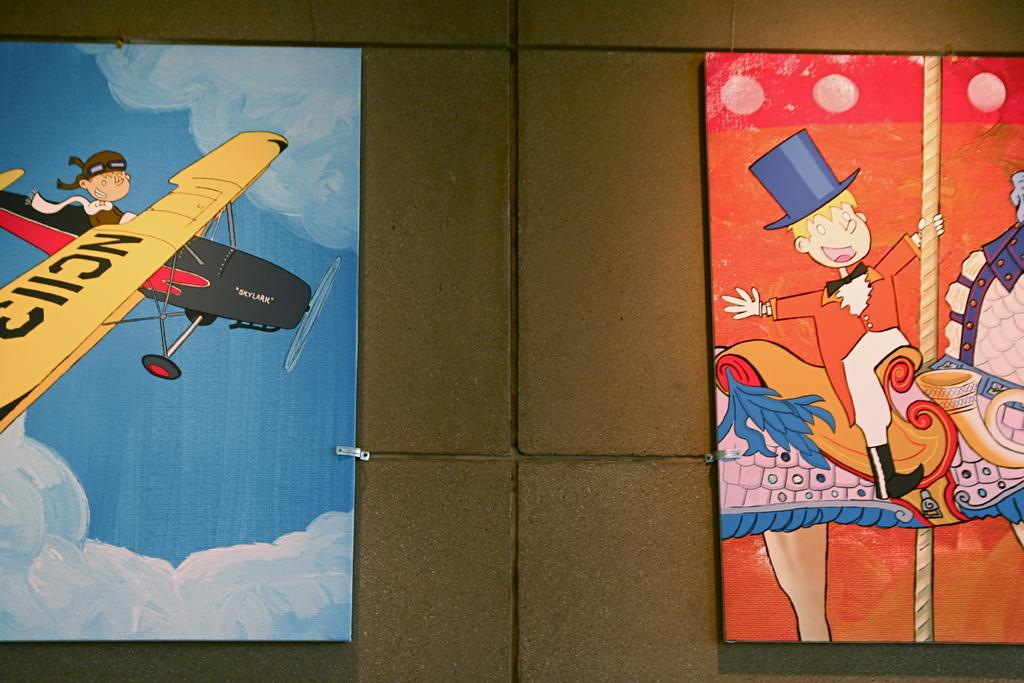What type of decorations are on the wall in the image? There are cartoon boards on the wall in the image. What type of silverware is being used to create a rhythm in the image? There is no silverware or rhythm present in the image; it features cartoon boards on the wall. 